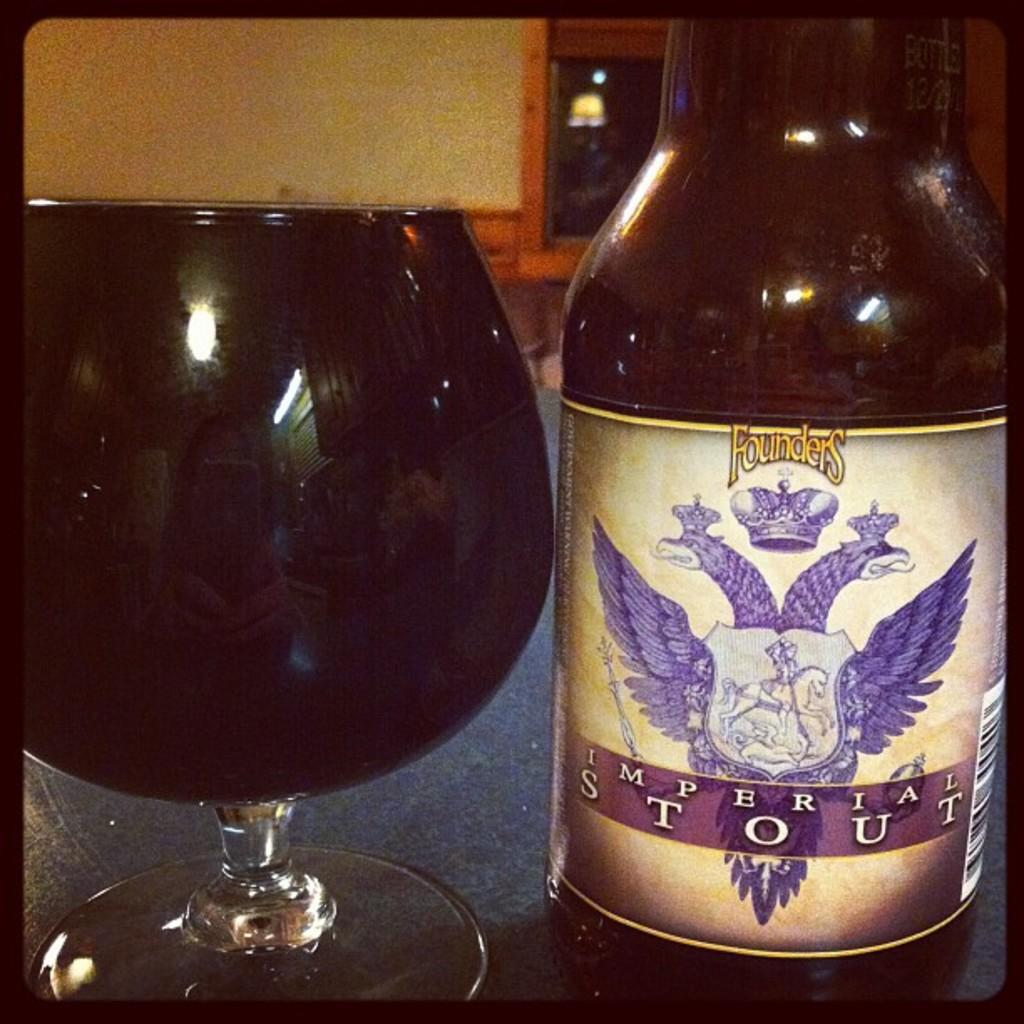<image>
Summarize the visual content of the image. A large glass next to a bottle of Imperial Stout 